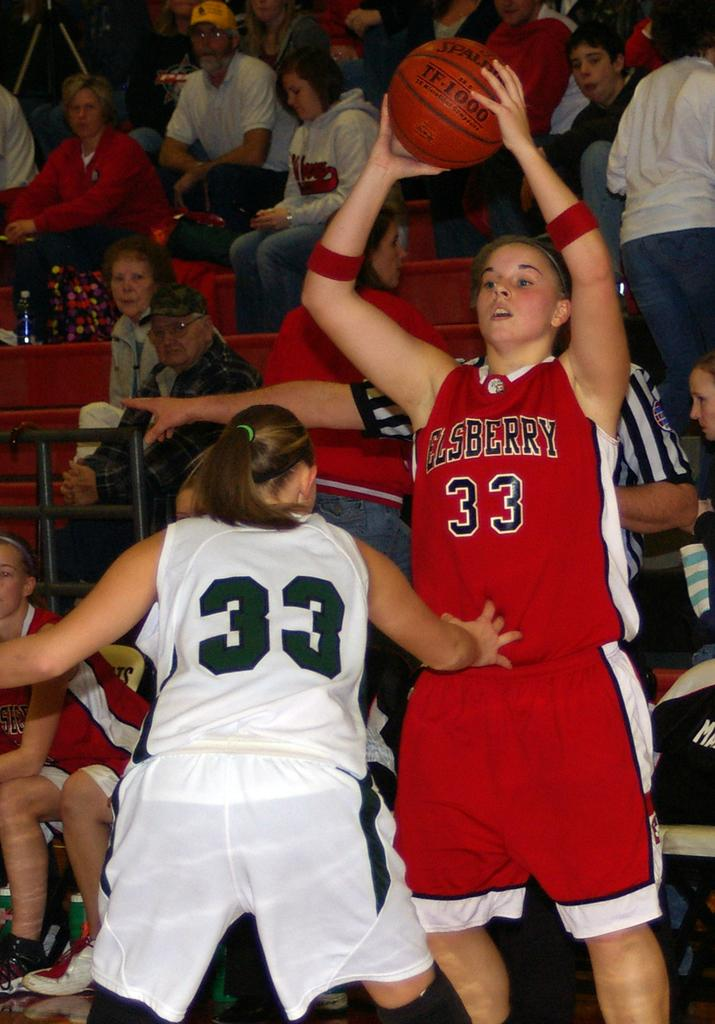Provide a one-sentence caption for the provided image. A blonde female basketball player wearing an Elsberry 33 jersey shoots the ball. 